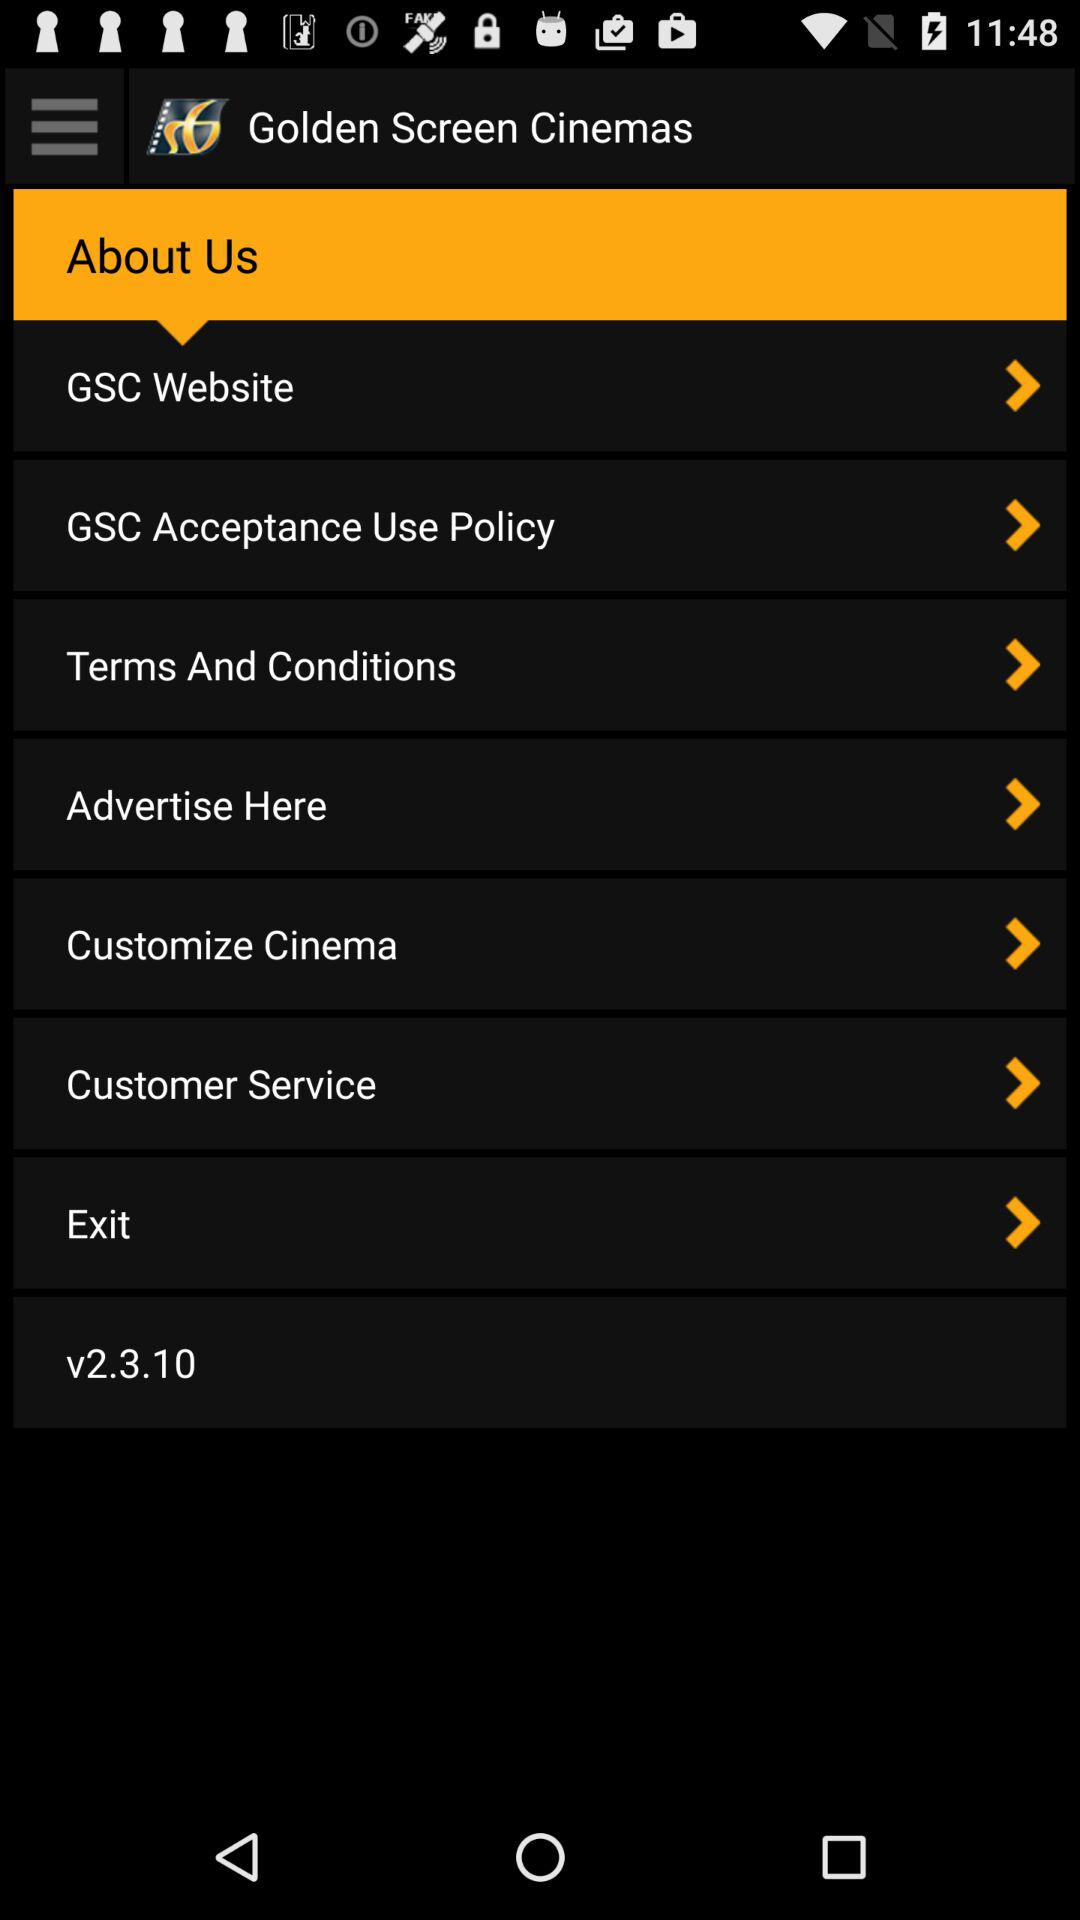What is the application name? The application name is "Golden Screen Cinemas". 